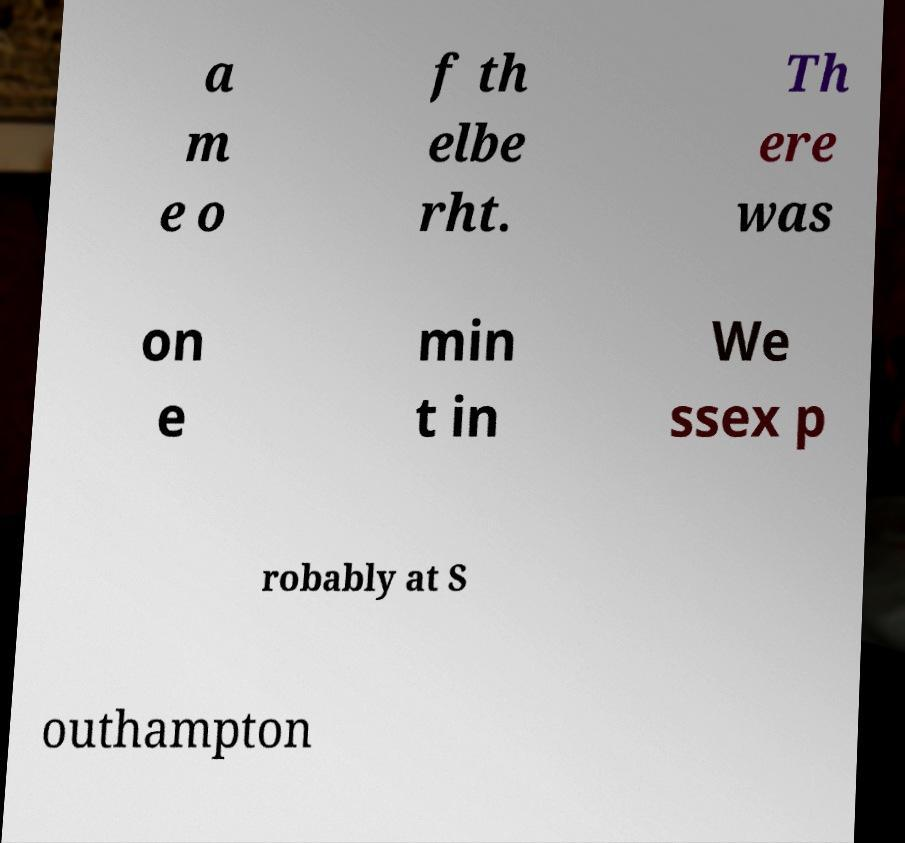Please identify and transcribe the text found in this image. a m e o f th elbe rht. Th ere was on e min t in We ssex p robably at S outhampton 